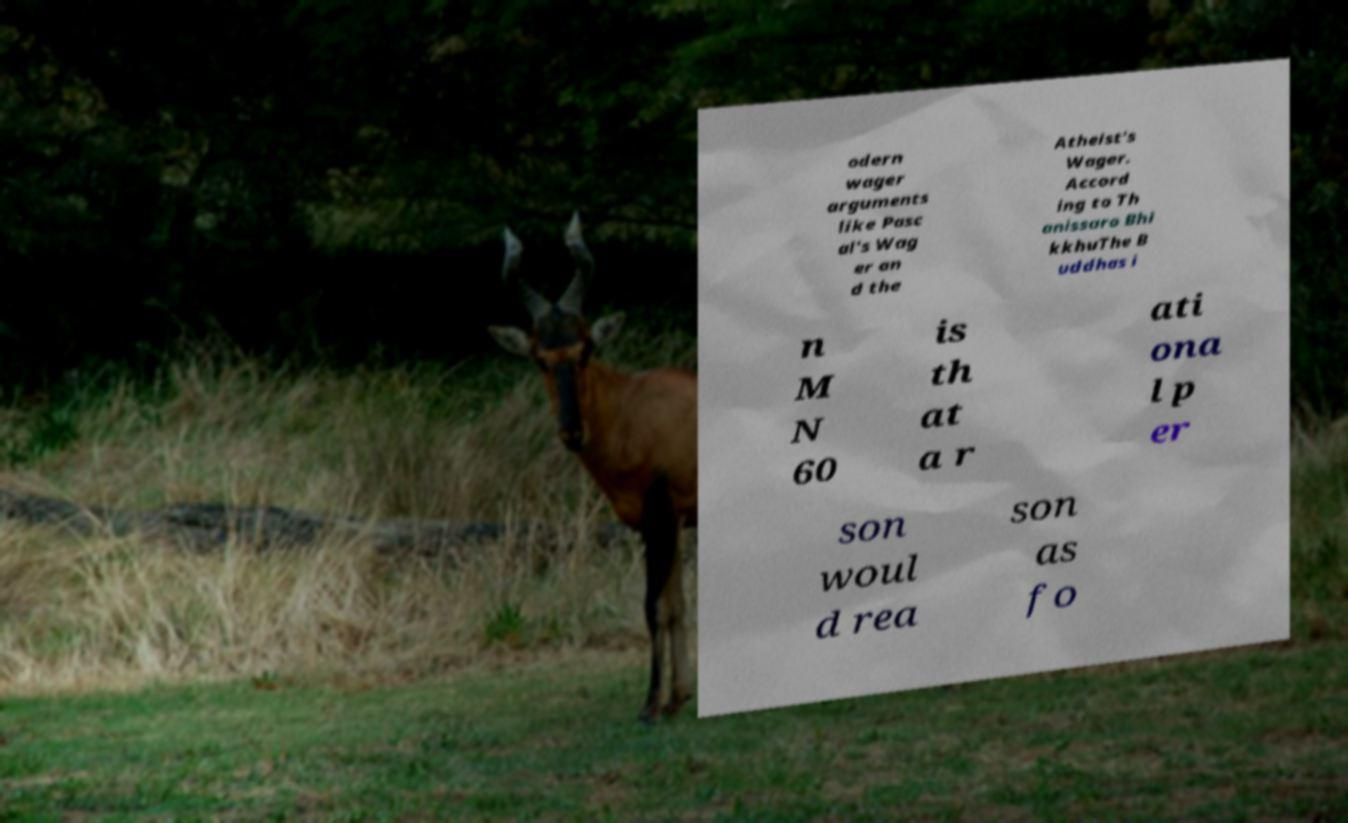What messages or text are displayed in this image? I need them in a readable, typed format. odern wager arguments like Pasc al's Wag er an d the Atheist's Wager. Accord ing to Th anissaro Bhi kkhuThe B uddhas i n M N 60 is th at a r ati ona l p er son woul d rea son as fo 